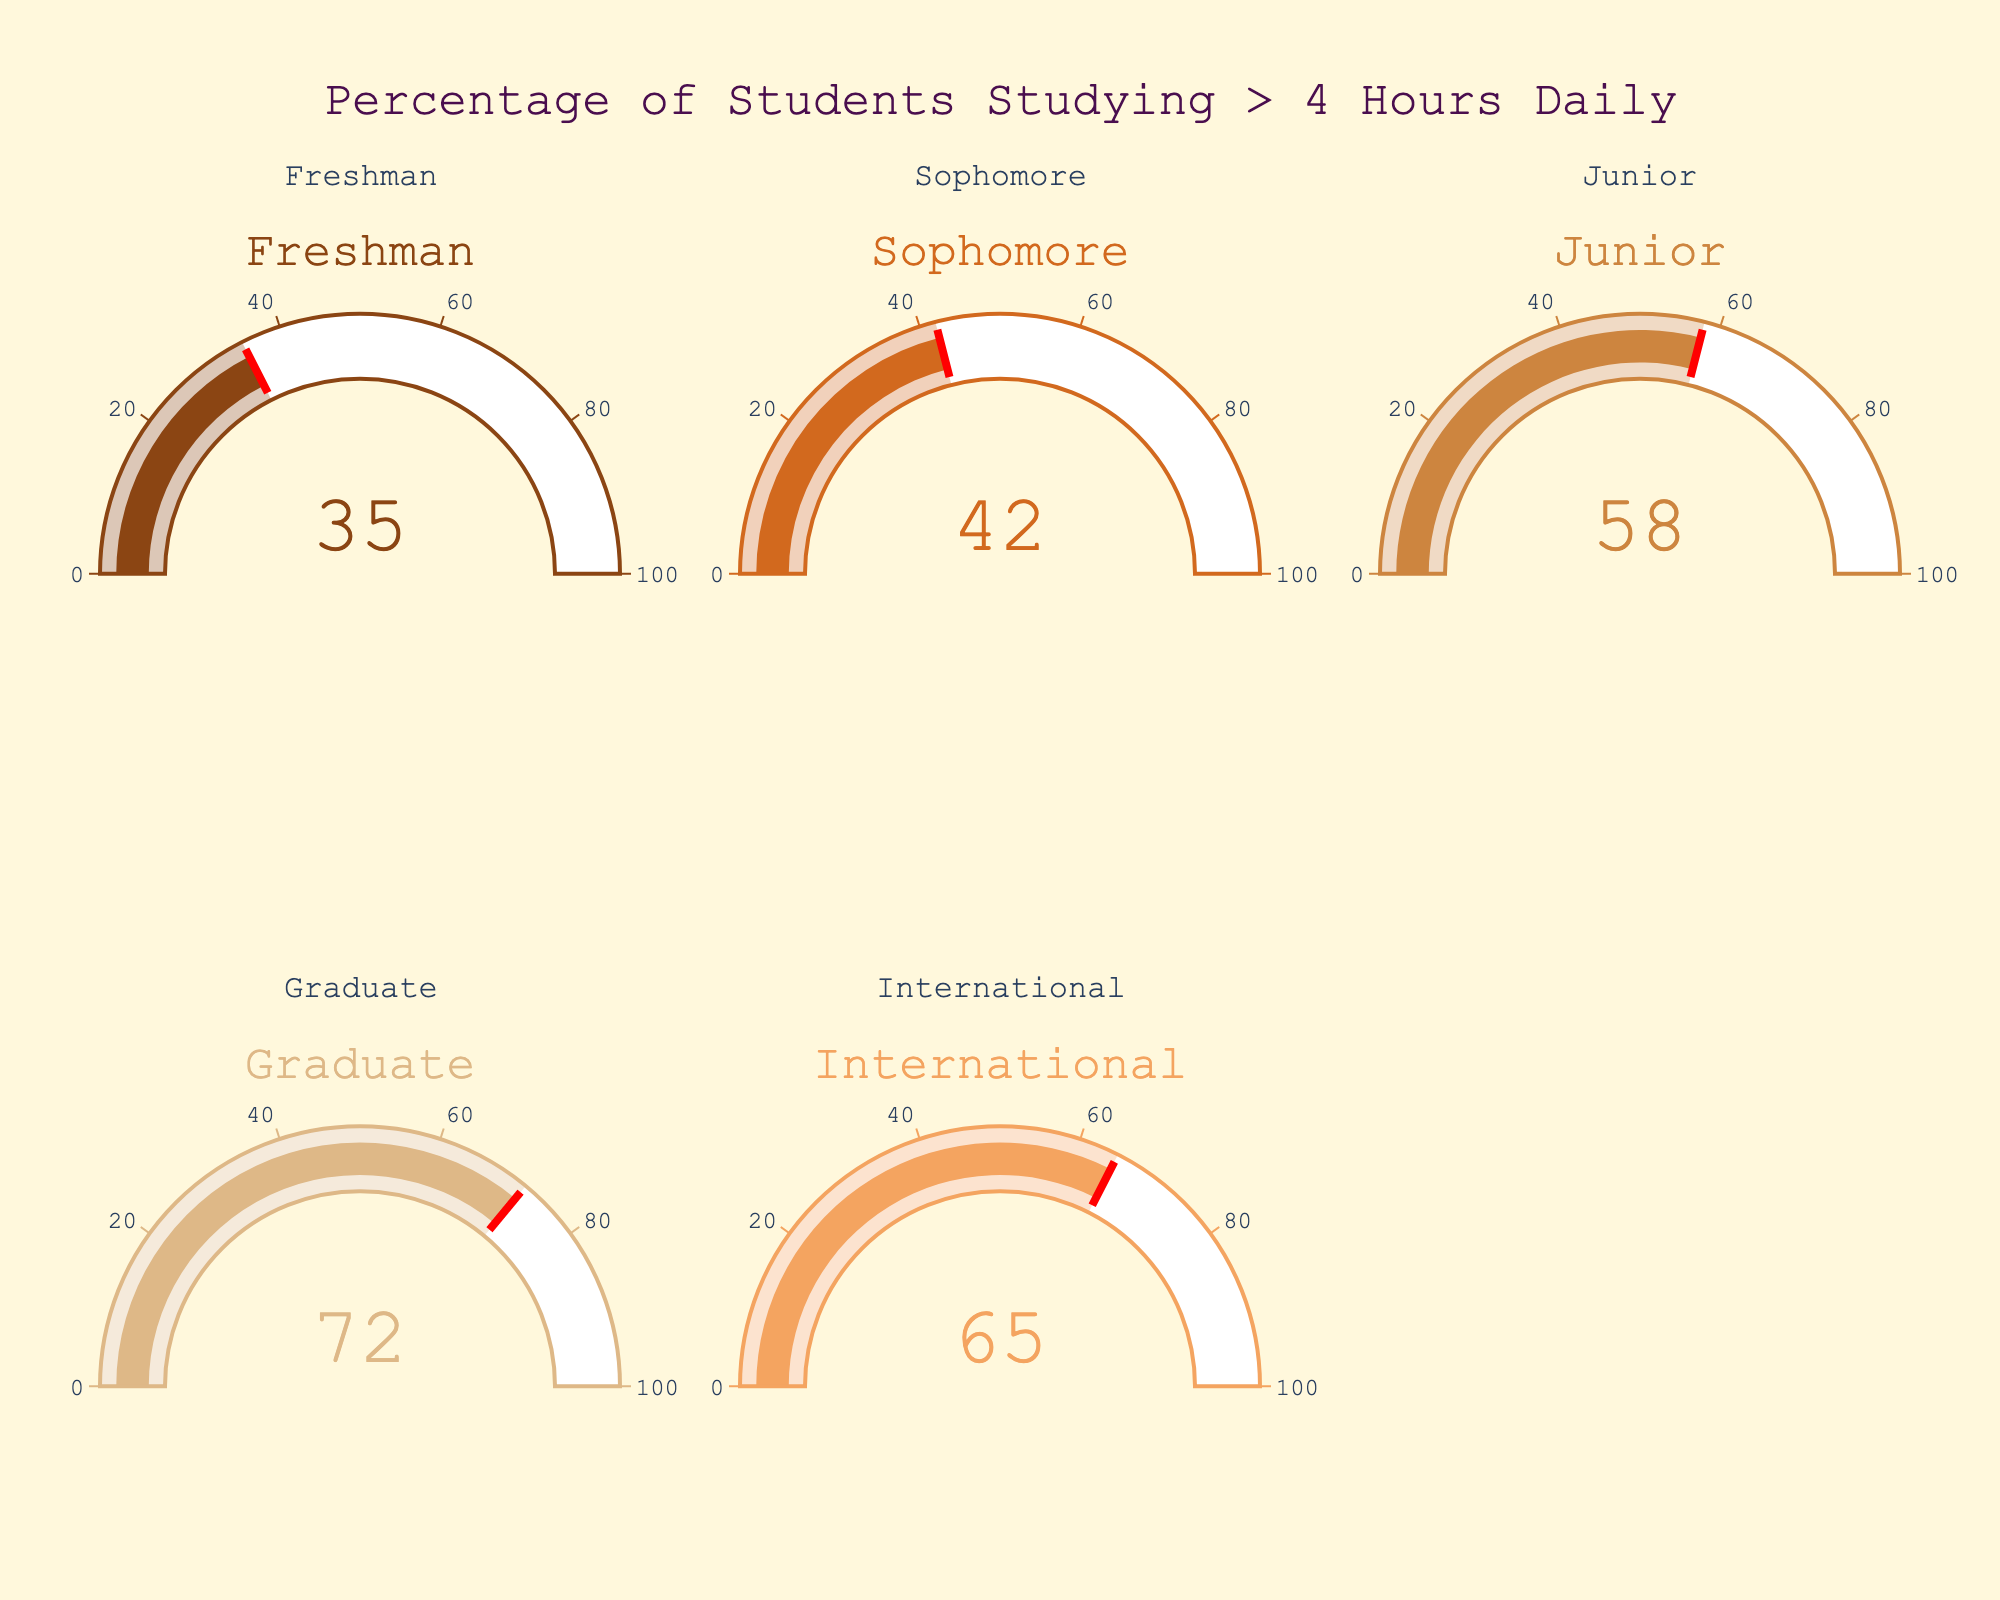What's the percentage of graduate students who study more than 4 hours per day? Look at the gauge chart corresponding to 'Graduate'. The needle points to the number 72.
Answer: 72 How many student categories are shown in the figure? The figure consists of five gauge charts each representing a different student category. Count each one.
Answer: 5 What's the difference in percentage between International and Freshman students studying more than 4 hours per day? Look at the values for International (65) and Freshman (35). Subtract the two numbers: 65 - 35 = 30.
Answer: 30 Which group has the highest percentage of students studying more than 4 hours per day? Compare the values shown on each gauge. Graduate has the highest percentage with a value of 72.
Answer: Graduate What's the average percentage of students across all categories who study more than 4 hours per day? Sum the values (35 + 42 + 58 + 72 + 65) = 272. Divide by the number of categories: 272 ÷ 5 = 54.4.
Answer: 54.4 Which group has a percentage closest to 50% of students studying more than 4 hours per day? Look at each gauge. Junior is closest to 50% with a percentage of 58.
Answer: Junior What is the second highest percentage value among the student categories? Arrange the percentages in descending order: 72, 65, 58, 42, 35. The second highest value is 65.
Answer: 65 Are there more categories with a percentage above or below 50% of students studying more than 4 hours per day? Identify categories above 50%: Junior (58), Graduate (72), International (65). Identify below 50%: Freshman (35), Sophomore (42). There are 3 categories above and 2 below.
Answer: Above Which two categories have the smallest gap in their percentages of students studying more than 4 hours per day? Calculate the gaps: Freshman-Sophomore (42-35=7), Sophomore-Junior (58-42=16), Junior-Graduate (72-58=14), Graduate-International (72-65=7). Freshman-Sophomore and Graduate-International both have the smallest gap of 7.
Answer: Freshman-Sophomore and Graduate-International 